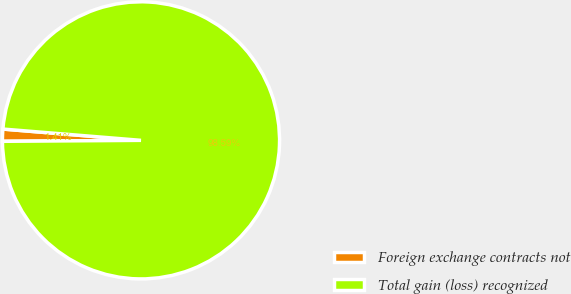<chart> <loc_0><loc_0><loc_500><loc_500><pie_chart><fcel>Foreign exchange contracts not<fcel>Total gain (loss) recognized<nl><fcel>1.41%<fcel>98.59%<nl></chart> 